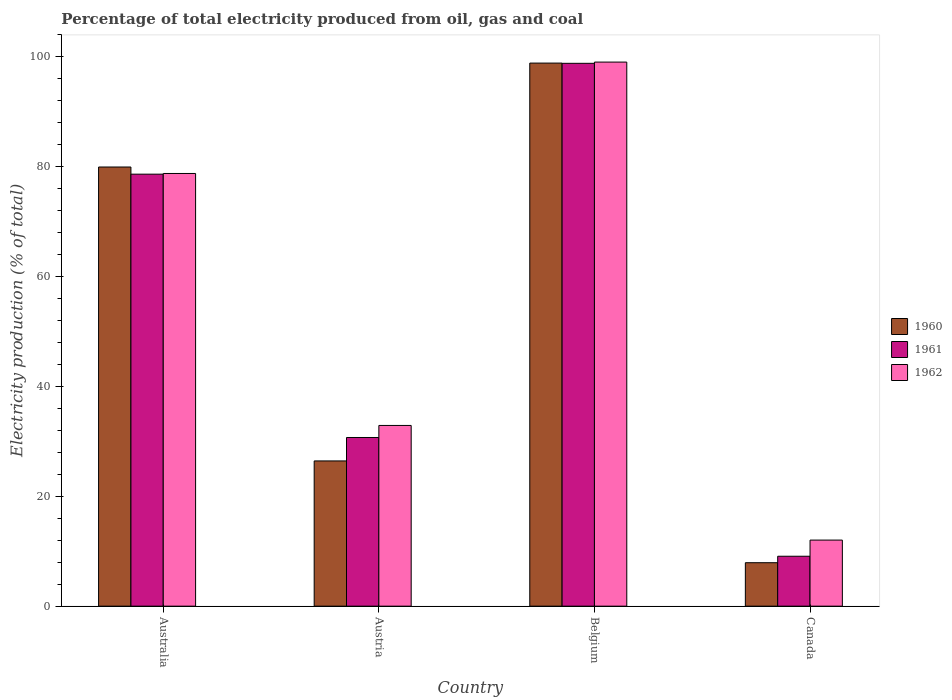How many different coloured bars are there?
Provide a succinct answer. 3. Are the number of bars per tick equal to the number of legend labels?
Provide a succinct answer. Yes. Are the number of bars on each tick of the X-axis equal?
Provide a succinct answer. Yes. How many bars are there on the 4th tick from the left?
Provide a succinct answer. 3. How many bars are there on the 1st tick from the right?
Offer a terse response. 3. What is the label of the 4th group of bars from the left?
Offer a very short reply. Canada. In how many cases, is the number of bars for a given country not equal to the number of legend labels?
Offer a terse response. 0. What is the electricity production in in 1961 in Belgium?
Provide a short and direct response. 98.82. Across all countries, what is the maximum electricity production in in 1960?
Provide a short and direct response. 98.86. Across all countries, what is the minimum electricity production in in 1960?
Offer a terse response. 7.91. In which country was the electricity production in in 1960 minimum?
Offer a very short reply. Canada. What is the total electricity production in in 1961 in the graph?
Your answer should be very brief. 217.26. What is the difference between the electricity production in in 1962 in Australia and that in Belgium?
Your response must be concise. -20.28. What is the difference between the electricity production in in 1962 in Australia and the electricity production in in 1960 in Austria?
Ensure brevity in your answer.  52.33. What is the average electricity production in in 1962 per country?
Offer a very short reply. 55.69. What is the difference between the electricity production in of/in 1962 and electricity production in of/in 1960 in Belgium?
Your answer should be compact. 0.18. In how many countries, is the electricity production in in 1962 greater than 84 %?
Provide a short and direct response. 1. What is the ratio of the electricity production in in 1960 in Belgium to that in Canada?
Keep it short and to the point. 12.5. What is the difference between the highest and the second highest electricity production in in 1960?
Your answer should be compact. 72.42. What is the difference between the highest and the lowest electricity production in in 1962?
Your answer should be very brief. 87.02. In how many countries, is the electricity production in in 1961 greater than the average electricity production in in 1961 taken over all countries?
Provide a succinct answer. 2. What does the 2nd bar from the left in Australia represents?
Ensure brevity in your answer.  1961. What does the 3rd bar from the right in Australia represents?
Provide a short and direct response. 1960. Does the graph contain any zero values?
Make the answer very short. No. Does the graph contain grids?
Offer a very short reply. No. How many legend labels are there?
Make the answer very short. 3. How are the legend labels stacked?
Offer a very short reply. Vertical. What is the title of the graph?
Give a very brief answer. Percentage of total electricity produced from oil, gas and coal. Does "1995" appear as one of the legend labels in the graph?
Give a very brief answer. No. What is the label or title of the Y-axis?
Keep it short and to the point. Electricity production (% of total). What is the Electricity production (% of total) in 1960 in Australia?
Provide a succinct answer. 79.95. What is the Electricity production (% of total) of 1961 in Australia?
Ensure brevity in your answer.  78.65. What is the Electricity production (% of total) in 1962 in Australia?
Your answer should be very brief. 78.77. What is the Electricity production (% of total) in 1960 in Austria?
Give a very brief answer. 26.44. What is the Electricity production (% of total) in 1961 in Austria?
Make the answer very short. 30.71. What is the Electricity production (% of total) of 1962 in Austria?
Provide a short and direct response. 32.9. What is the Electricity production (% of total) of 1960 in Belgium?
Keep it short and to the point. 98.86. What is the Electricity production (% of total) in 1961 in Belgium?
Offer a very short reply. 98.82. What is the Electricity production (% of total) in 1962 in Belgium?
Offer a very short reply. 99.05. What is the Electricity production (% of total) in 1960 in Canada?
Make the answer very short. 7.91. What is the Electricity production (% of total) in 1961 in Canada?
Your answer should be compact. 9.09. What is the Electricity production (% of total) in 1962 in Canada?
Keep it short and to the point. 12.03. Across all countries, what is the maximum Electricity production (% of total) of 1960?
Ensure brevity in your answer.  98.86. Across all countries, what is the maximum Electricity production (% of total) of 1961?
Provide a succinct answer. 98.82. Across all countries, what is the maximum Electricity production (% of total) of 1962?
Provide a short and direct response. 99.05. Across all countries, what is the minimum Electricity production (% of total) in 1960?
Give a very brief answer. 7.91. Across all countries, what is the minimum Electricity production (% of total) of 1961?
Ensure brevity in your answer.  9.09. Across all countries, what is the minimum Electricity production (% of total) in 1962?
Give a very brief answer. 12.03. What is the total Electricity production (% of total) in 1960 in the graph?
Offer a very short reply. 213.16. What is the total Electricity production (% of total) in 1961 in the graph?
Provide a succinct answer. 217.26. What is the total Electricity production (% of total) in 1962 in the graph?
Your response must be concise. 222.75. What is the difference between the Electricity production (% of total) of 1960 in Australia and that in Austria?
Offer a very short reply. 53.51. What is the difference between the Electricity production (% of total) of 1961 in Australia and that in Austria?
Your response must be concise. 47.94. What is the difference between the Electricity production (% of total) of 1962 in Australia and that in Austria?
Give a very brief answer. 45.87. What is the difference between the Electricity production (% of total) of 1960 in Australia and that in Belgium?
Provide a short and direct response. -18.92. What is the difference between the Electricity production (% of total) of 1961 in Australia and that in Belgium?
Your answer should be very brief. -20.18. What is the difference between the Electricity production (% of total) in 1962 in Australia and that in Belgium?
Keep it short and to the point. -20.28. What is the difference between the Electricity production (% of total) in 1960 in Australia and that in Canada?
Offer a terse response. 72.04. What is the difference between the Electricity production (% of total) in 1961 in Australia and that in Canada?
Provide a succinct answer. 69.56. What is the difference between the Electricity production (% of total) in 1962 in Australia and that in Canada?
Make the answer very short. 66.74. What is the difference between the Electricity production (% of total) of 1960 in Austria and that in Belgium?
Your answer should be very brief. -72.42. What is the difference between the Electricity production (% of total) of 1961 in Austria and that in Belgium?
Keep it short and to the point. -68.11. What is the difference between the Electricity production (% of total) of 1962 in Austria and that in Belgium?
Give a very brief answer. -66.15. What is the difference between the Electricity production (% of total) in 1960 in Austria and that in Canada?
Your answer should be compact. 18.53. What is the difference between the Electricity production (% of total) in 1961 in Austria and that in Canada?
Provide a short and direct response. 21.62. What is the difference between the Electricity production (% of total) of 1962 in Austria and that in Canada?
Ensure brevity in your answer.  20.87. What is the difference between the Electricity production (% of total) in 1960 in Belgium and that in Canada?
Offer a terse response. 90.95. What is the difference between the Electricity production (% of total) of 1961 in Belgium and that in Canada?
Your response must be concise. 89.73. What is the difference between the Electricity production (% of total) of 1962 in Belgium and that in Canada?
Give a very brief answer. 87.02. What is the difference between the Electricity production (% of total) of 1960 in Australia and the Electricity production (% of total) of 1961 in Austria?
Your response must be concise. 49.24. What is the difference between the Electricity production (% of total) of 1960 in Australia and the Electricity production (% of total) of 1962 in Austria?
Provide a succinct answer. 47.05. What is the difference between the Electricity production (% of total) of 1961 in Australia and the Electricity production (% of total) of 1962 in Austria?
Provide a succinct answer. 45.74. What is the difference between the Electricity production (% of total) in 1960 in Australia and the Electricity production (% of total) in 1961 in Belgium?
Offer a terse response. -18.87. What is the difference between the Electricity production (% of total) of 1960 in Australia and the Electricity production (% of total) of 1962 in Belgium?
Make the answer very short. -19.1. What is the difference between the Electricity production (% of total) of 1961 in Australia and the Electricity production (% of total) of 1962 in Belgium?
Provide a short and direct response. -20.4. What is the difference between the Electricity production (% of total) in 1960 in Australia and the Electricity production (% of total) in 1961 in Canada?
Your answer should be very brief. 70.86. What is the difference between the Electricity production (% of total) of 1960 in Australia and the Electricity production (% of total) of 1962 in Canada?
Keep it short and to the point. 67.92. What is the difference between the Electricity production (% of total) in 1961 in Australia and the Electricity production (% of total) in 1962 in Canada?
Offer a terse response. 66.61. What is the difference between the Electricity production (% of total) in 1960 in Austria and the Electricity production (% of total) in 1961 in Belgium?
Provide a short and direct response. -72.38. What is the difference between the Electricity production (% of total) of 1960 in Austria and the Electricity production (% of total) of 1962 in Belgium?
Offer a very short reply. -72.61. What is the difference between the Electricity production (% of total) in 1961 in Austria and the Electricity production (% of total) in 1962 in Belgium?
Your response must be concise. -68.34. What is the difference between the Electricity production (% of total) in 1960 in Austria and the Electricity production (% of total) in 1961 in Canada?
Your answer should be very brief. 17.35. What is the difference between the Electricity production (% of total) of 1960 in Austria and the Electricity production (% of total) of 1962 in Canada?
Give a very brief answer. 14.41. What is the difference between the Electricity production (% of total) of 1961 in Austria and the Electricity production (% of total) of 1962 in Canada?
Your answer should be very brief. 18.67. What is the difference between the Electricity production (% of total) in 1960 in Belgium and the Electricity production (% of total) in 1961 in Canada?
Keep it short and to the point. 89.78. What is the difference between the Electricity production (% of total) of 1960 in Belgium and the Electricity production (% of total) of 1962 in Canada?
Your answer should be very brief. 86.83. What is the difference between the Electricity production (% of total) in 1961 in Belgium and the Electricity production (% of total) in 1962 in Canada?
Make the answer very short. 86.79. What is the average Electricity production (% of total) in 1960 per country?
Keep it short and to the point. 53.29. What is the average Electricity production (% of total) of 1961 per country?
Provide a short and direct response. 54.32. What is the average Electricity production (% of total) of 1962 per country?
Provide a short and direct response. 55.69. What is the difference between the Electricity production (% of total) of 1960 and Electricity production (% of total) of 1961 in Australia?
Ensure brevity in your answer.  1.3. What is the difference between the Electricity production (% of total) of 1960 and Electricity production (% of total) of 1962 in Australia?
Your response must be concise. 1.18. What is the difference between the Electricity production (% of total) of 1961 and Electricity production (% of total) of 1962 in Australia?
Offer a terse response. -0.12. What is the difference between the Electricity production (% of total) in 1960 and Electricity production (% of total) in 1961 in Austria?
Provide a succinct answer. -4.27. What is the difference between the Electricity production (% of total) in 1960 and Electricity production (% of total) in 1962 in Austria?
Make the answer very short. -6.46. What is the difference between the Electricity production (% of total) in 1961 and Electricity production (% of total) in 1962 in Austria?
Offer a terse response. -2.19. What is the difference between the Electricity production (% of total) in 1960 and Electricity production (% of total) in 1961 in Belgium?
Provide a succinct answer. 0.04. What is the difference between the Electricity production (% of total) in 1960 and Electricity production (% of total) in 1962 in Belgium?
Give a very brief answer. -0.18. What is the difference between the Electricity production (% of total) of 1961 and Electricity production (% of total) of 1962 in Belgium?
Offer a very short reply. -0.23. What is the difference between the Electricity production (% of total) in 1960 and Electricity production (% of total) in 1961 in Canada?
Offer a very short reply. -1.18. What is the difference between the Electricity production (% of total) of 1960 and Electricity production (% of total) of 1962 in Canada?
Give a very brief answer. -4.12. What is the difference between the Electricity production (% of total) of 1961 and Electricity production (% of total) of 1962 in Canada?
Offer a very short reply. -2.94. What is the ratio of the Electricity production (% of total) in 1960 in Australia to that in Austria?
Offer a very short reply. 3.02. What is the ratio of the Electricity production (% of total) in 1961 in Australia to that in Austria?
Offer a terse response. 2.56. What is the ratio of the Electricity production (% of total) of 1962 in Australia to that in Austria?
Offer a terse response. 2.39. What is the ratio of the Electricity production (% of total) in 1960 in Australia to that in Belgium?
Ensure brevity in your answer.  0.81. What is the ratio of the Electricity production (% of total) of 1961 in Australia to that in Belgium?
Your answer should be very brief. 0.8. What is the ratio of the Electricity production (% of total) in 1962 in Australia to that in Belgium?
Offer a very short reply. 0.8. What is the ratio of the Electricity production (% of total) of 1960 in Australia to that in Canada?
Ensure brevity in your answer.  10.11. What is the ratio of the Electricity production (% of total) in 1961 in Australia to that in Canada?
Ensure brevity in your answer.  8.65. What is the ratio of the Electricity production (% of total) of 1962 in Australia to that in Canada?
Offer a terse response. 6.55. What is the ratio of the Electricity production (% of total) of 1960 in Austria to that in Belgium?
Keep it short and to the point. 0.27. What is the ratio of the Electricity production (% of total) of 1961 in Austria to that in Belgium?
Provide a short and direct response. 0.31. What is the ratio of the Electricity production (% of total) in 1962 in Austria to that in Belgium?
Offer a very short reply. 0.33. What is the ratio of the Electricity production (% of total) in 1960 in Austria to that in Canada?
Your answer should be very brief. 3.34. What is the ratio of the Electricity production (% of total) of 1961 in Austria to that in Canada?
Your answer should be very brief. 3.38. What is the ratio of the Electricity production (% of total) of 1962 in Austria to that in Canada?
Your response must be concise. 2.73. What is the ratio of the Electricity production (% of total) in 1960 in Belgium to that in Canada?
Keep it short and to the point. 12.5. What is the ratio of the Electricity production (% of total) of 1961 in Belgium to that in Canada?
Provide a short and direct response. 10.87. What is the ratio of the Electricity production (% of total) in 1962 in Belgium to that in Canada?
Offer a terse response. 8.23. What is the difference between the highest and the second highest Electricity production (% of total) in 1960?
Ensure brevity in your answer.  18.92. What is the difference between the highest and the second highest Electricity production (% of total) of 1961?
Offer a very short reply. 20.18. What is the difference between the highest and the second highest Electricity production (% of total) of 1962?
Make the answer very short. 20.28. What is the difference between the highest and the lowest Electricity production (% of total) of 1960?
Your answer should be compact. 90.95. What is the difference between the highest and the lowest Electricity production (% of total) in 1961?
Provide a succinct answer. 89.73. What is the difference between the highest and the lowest Electricity production (% of total) in 1962?
Give a very brief answer. 87.02. 